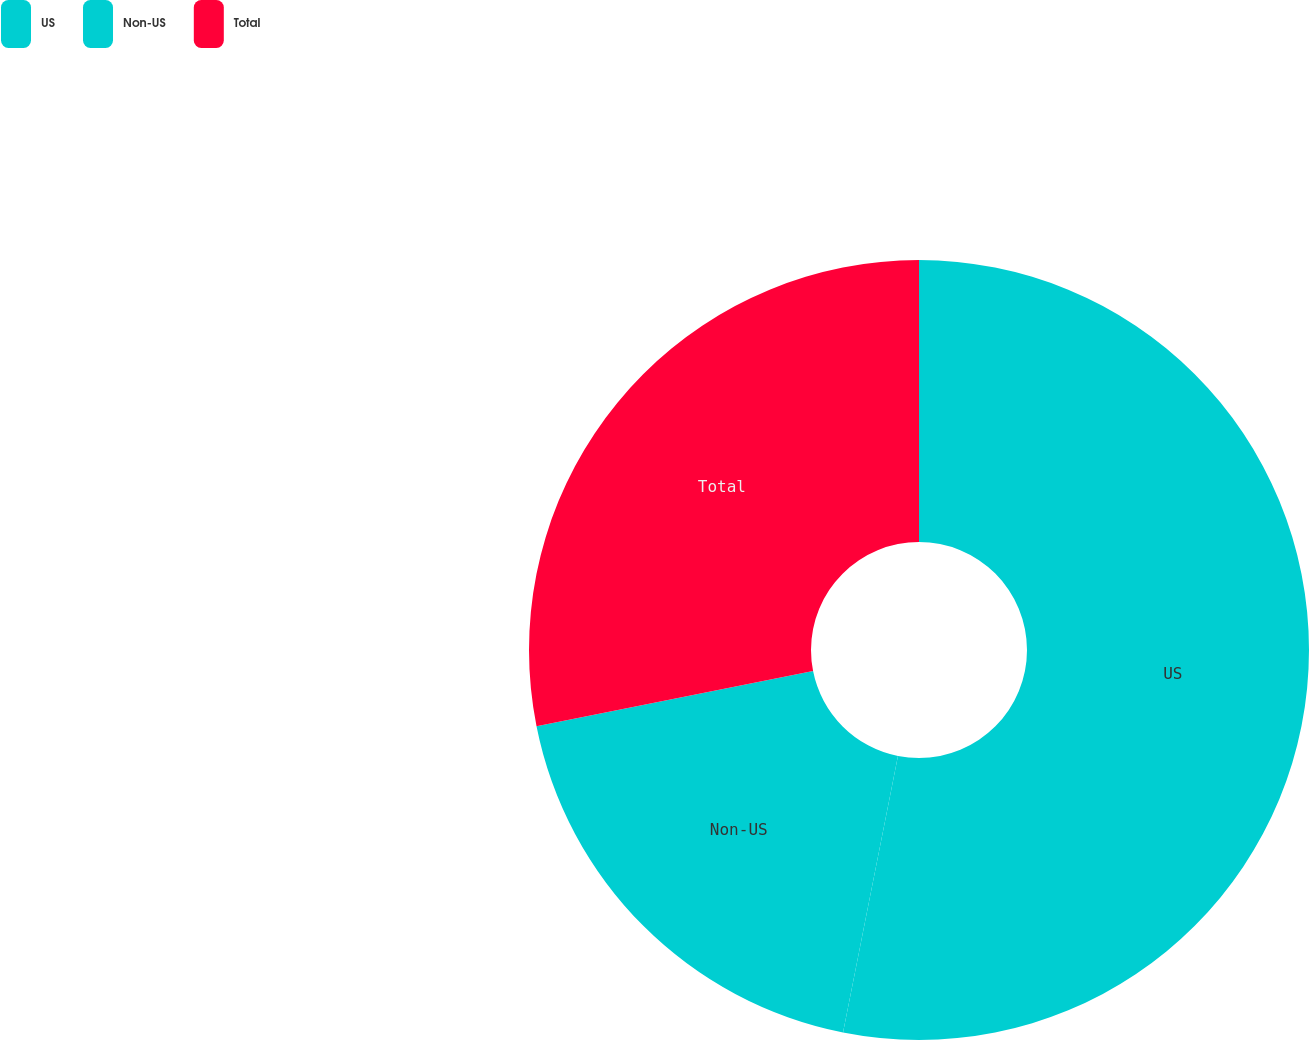Convert chart to OTSL. <chart><loc_0><loc_0><loc_500><loc_500><pie_chart><fcel>US<fcel>Non-US<fcel>Total<nl><fcel>53.12%<fcel>18.75%<fcel>28.13%<nl></chart> 